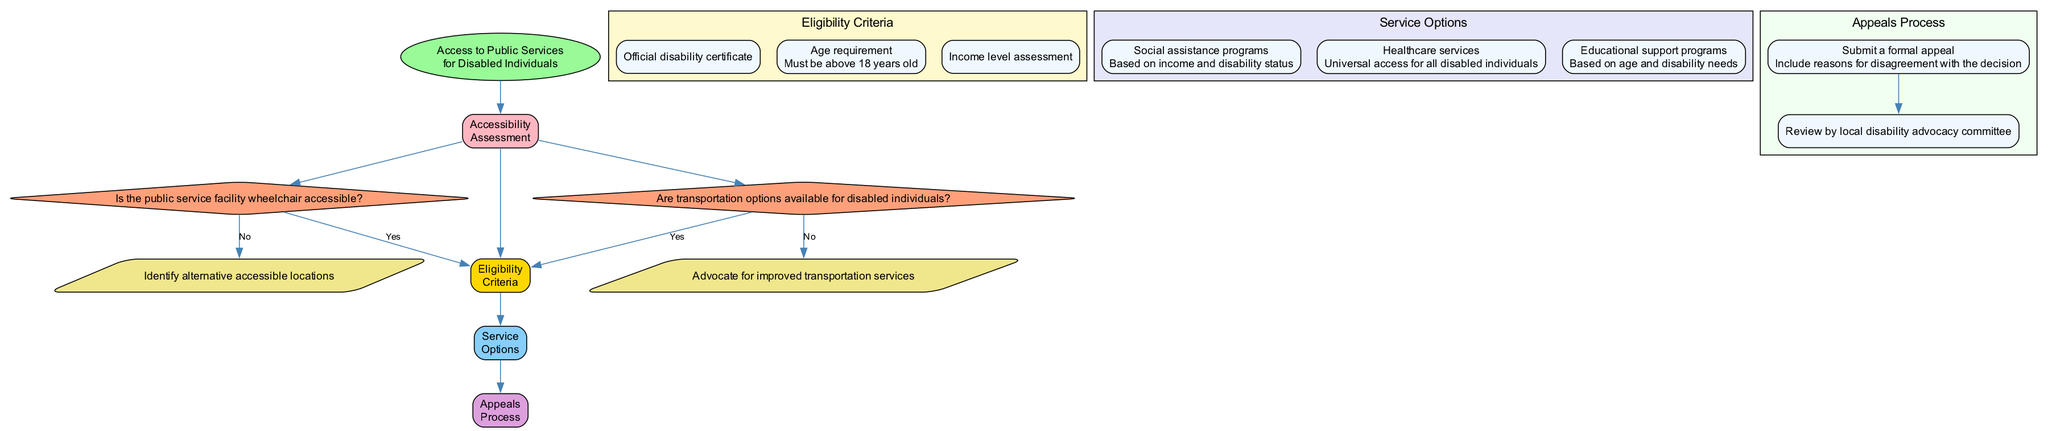What is the first step in accessing public services for disabled individuals? The diagram starts with "Accessibility Assessment," which is the first stage in the process.
Answer: Accessibility Assessment How many decision points are in the Accessibility Assessment? There are two decision points identified in the Accessibility Assessment: one for wheelchair accessibility and another for transportation options.
Answer: 2 What happens if the public service facility is not wheelchair accessible? If the facility is not wheelchair accessible, the next action is to "Identify alternative accessible locations."
Answer: Identify alternative accessible locations What is needed to qualify for public services? To qualify for public services, an "Official disability certificate" is needed among other criteria.
Answer: Official disability certificate What is the age requirement for eligibility? The eligibility criteria state that individuals must be "above 18 years old."
Answer: above 18 years old What services are available based on income and disability status? "Social assistance programs" are available based on income and disability status as per the service options.
Answer: Social assistance programs What is the final step in the appeals process? The final step is to review the case by the "local disability advocacy committee," which communicates the decision.
Answer: local disability advocacy committee What does the appeals process provide if services are denied? The appeals process provides a method for individuals to submit a "formal appeal" to contest the denial.
Answer: formal appeal What is the eligibility for healthcare services? The eligibility for healthcare services is described as "Universal access for all disabled individuals."
Answer: Universal access for all disabled individuals 